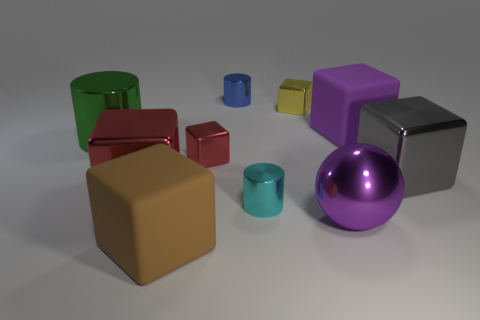Subtract all tiny cylinders. How many cylinders are left? 1 Subtract 1 spheres. How many spheres are left? 0 Subtract all yellow cubes. How many cubes are left? 5 Add 2 gray shiny objects. How many gray shiny objects exist? 3 Subtract 0 gray cylinders. How many objects are left? 10 Subtract all cylinders. How many objects are left? 7 Subtract all yellow balls. Subtract all brown cylinders. How many balls are left? 1 Subtract all green cubes. How many red spheres are left? 0 Subtract all big metal cylinders. Subtract all cubes. How many objects are left? 3 Add 7 balls. How many balls are left? 8 